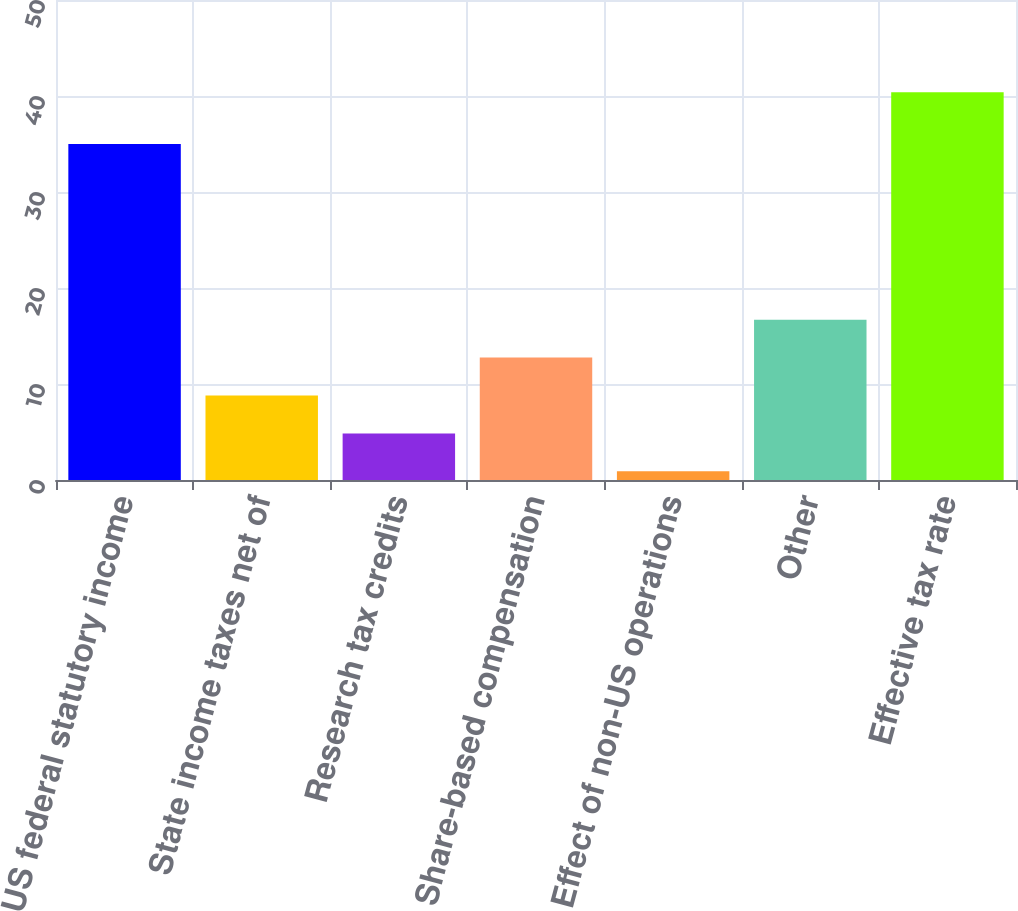Convert chart. <chart><loc_0><loc_0><loc_500><loc_500><bar_chart><fcel>US federal statutory income<fcel>State income taxes net of<fcel>Research tax credits<fcel>Share-based compensation<fcel>Effect of non-US operations<fcel>Other<fcel>Effective tax rate<nl><fcel>35<fcel>8.8<fcel>4.85<fcel>12.75<fcel>0.9<fcel>16.7<fcel>40.4<nl></chart> 